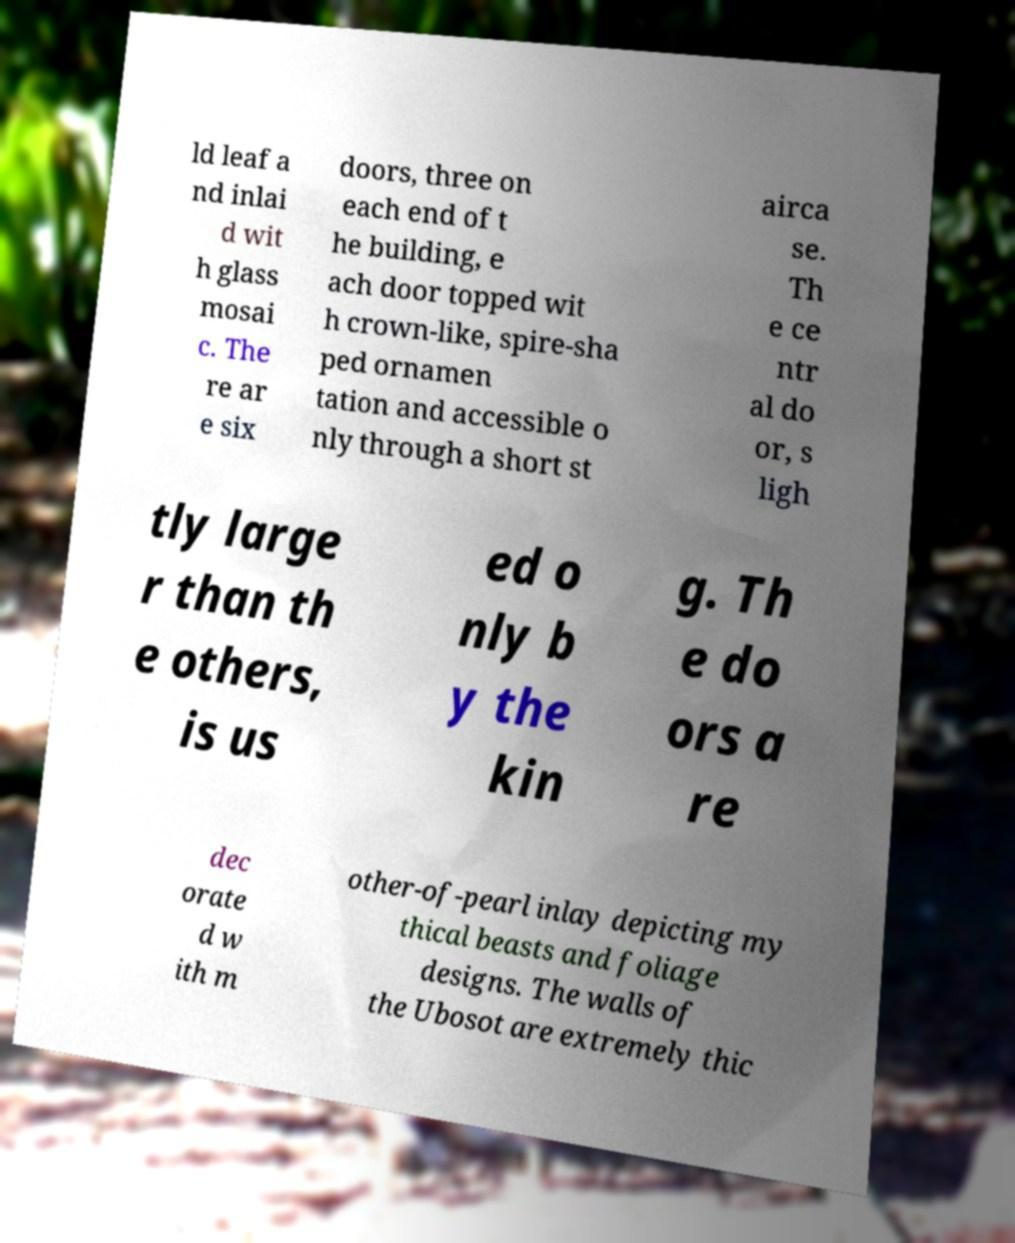For documentation purposes, I need the text within this image transcribed. Could you provide that? ld leaf a nd inlai d wit h glass mosai c. The re ar e six doors, three on each end of t he building, e ach door topped wit h crown-like, spire-sha ped ornamen tation and accessible o nly through a short st airca se. Th e ce ntr al do or, s ligh tly large r than th e others, is us ed o nly b y the kin g. Th e do ors a re dec orate d w ith m other-of-pearl inlay depicting my thical beasts and foliage designs. The walls of the Ubosot are extremely thic 